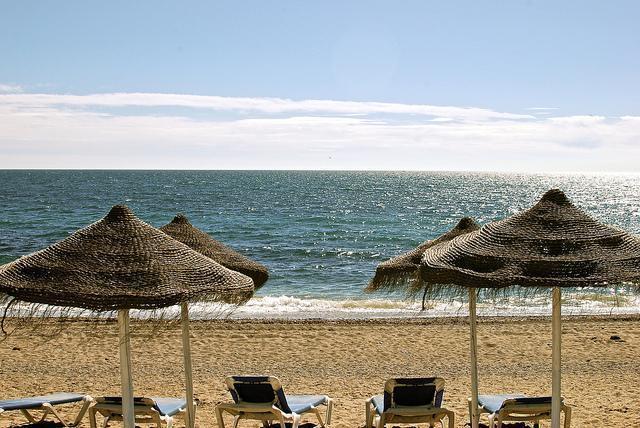How many people can sit in the lounge chairs?
Give a very brief answer. 5. How many chairs are there?
Give a very brief answer. 5. How many umbrellas are in the picture?
Give a very brief answer. 4. 